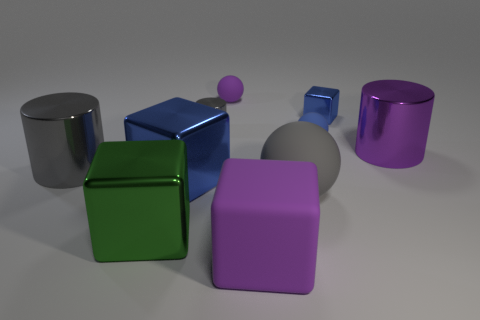Subtract all small blocks. How many blocks are left? 3 Subtract all purple spheres. How many spheres are left? 2 Subtract all balls. How many objects are left? 7 Subtract 3 cylinders. How many cylinders are left? 0 Subtract all purple spheres. Subtract all purple blocks. How many spheres are left? 2 Subtract all purple cylinders. How many red blocks are left? 0 Subtract all small cubes. Subtract all objects. How many objects are left? 8 Add 1 cylinders. How many cylinders are left? 4 Add 2 large red rubber things. How many large red rubber things exist? 2 Subtract 0 red blocks. How many objects are left? 10 